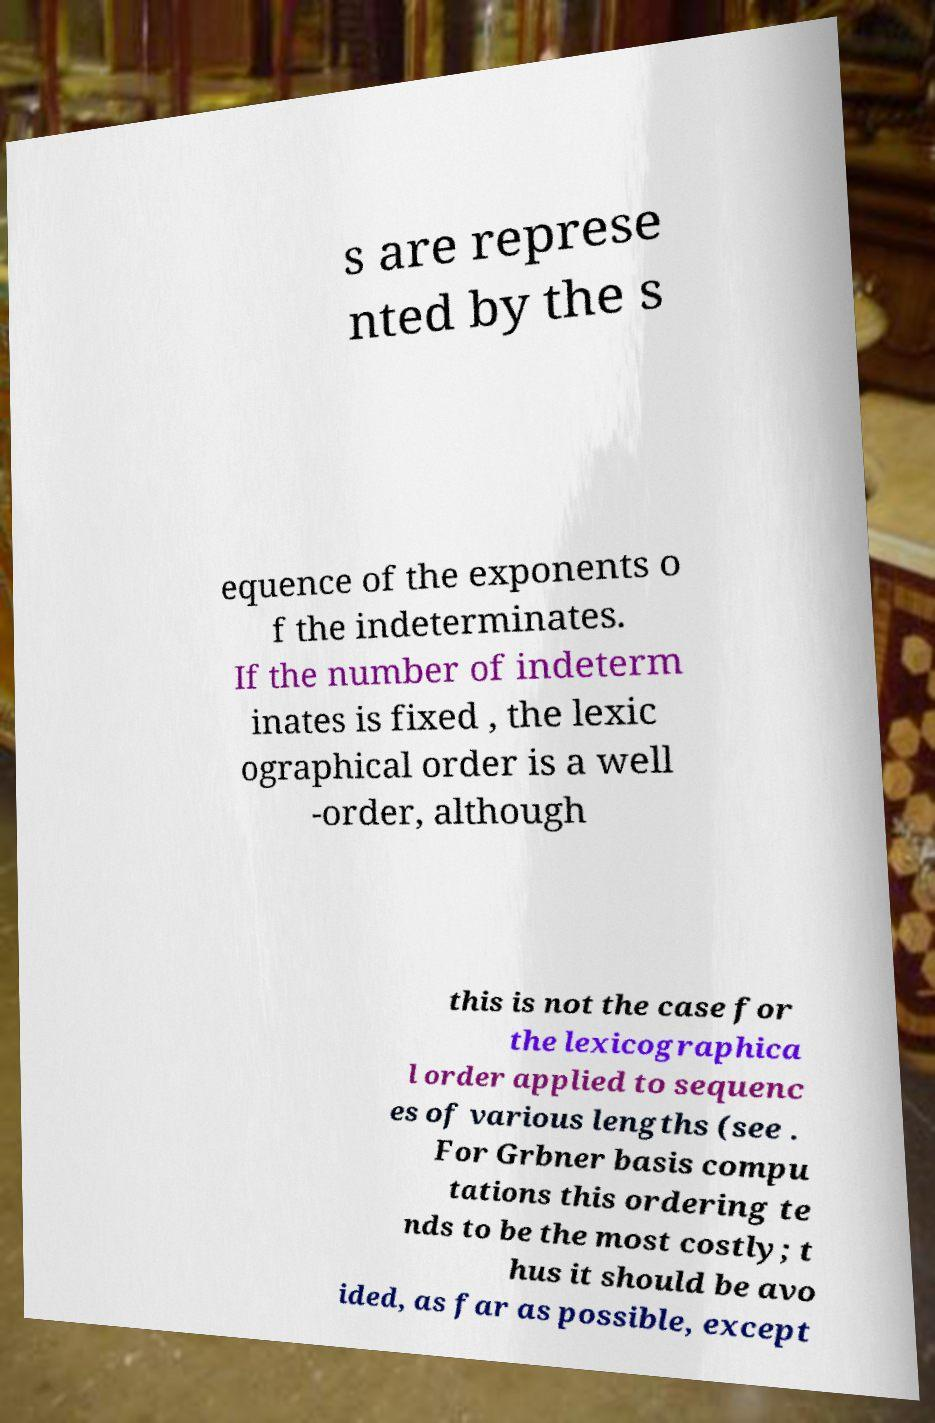I need the written content from this picture converted into text. Can you do that? s are represe nted by the s equence of the exponents o f the indeterminates. If the number of indeterm inates is fixed , the lexic ographical order is a well -order, although this is not the case for the lexicographica l order applied to sequenc es of various lengths (see . For Grbner basis compu tations this ordering te nds to be the most costly; t hus it should be avo ided, as far as possible, except 